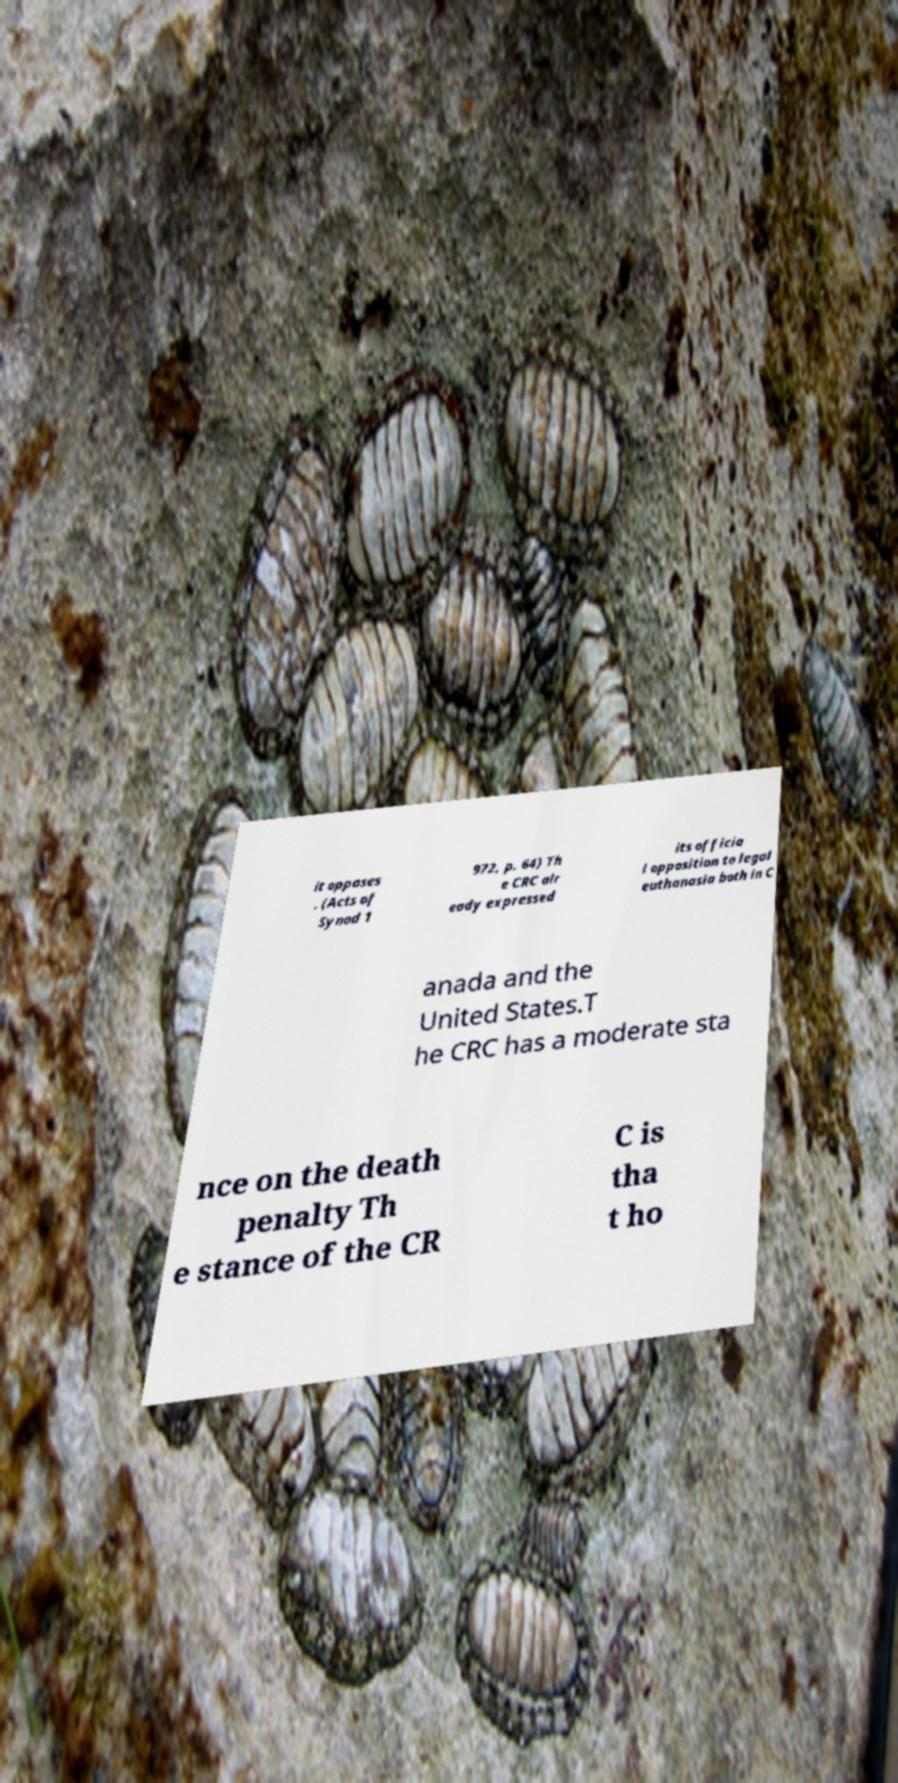There's text embedded in this image that I need extracted. Can you transcribe it verbatim? it opposes . (Acts of Synod 1 972, p. 64) Th e CRC alr eady expressed its officia l opposition to legal euthanasia both in C anada and the United States.T he CRC has a moderate sta nce on the death penalty Th e stance of the CR C is tha t ho 